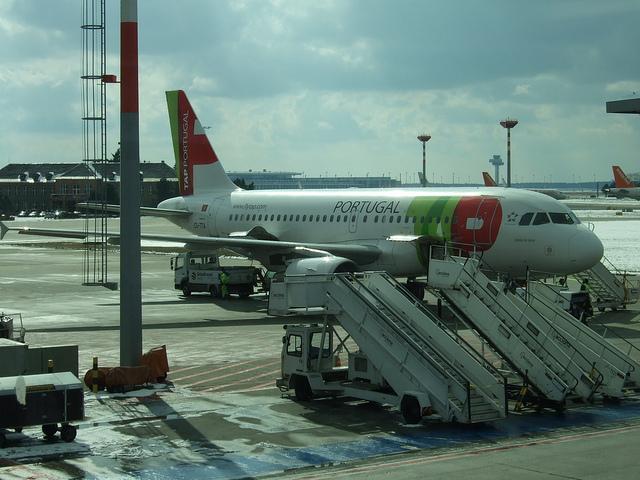How many airplanes are visible?
Be succinct. 1. What color is the plane?
Keep it brief. White. What is the country name on the side of the plane?
Give a very brief answer. Portugal. 